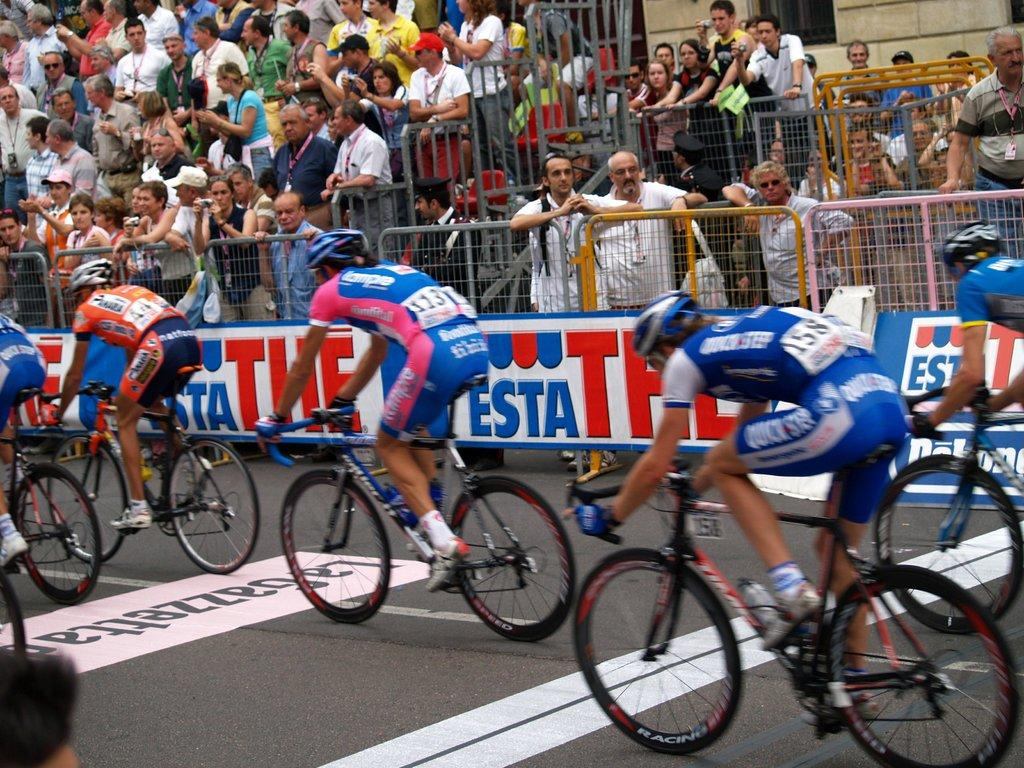<image>
Summarize the visual content of the image. Number 44 is the only rider not wearing blue in the group. 